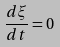<formula> <loc_0><loc_0><loc_500><loc_500>\frac { d \xi } { d t } = 0</formula> 